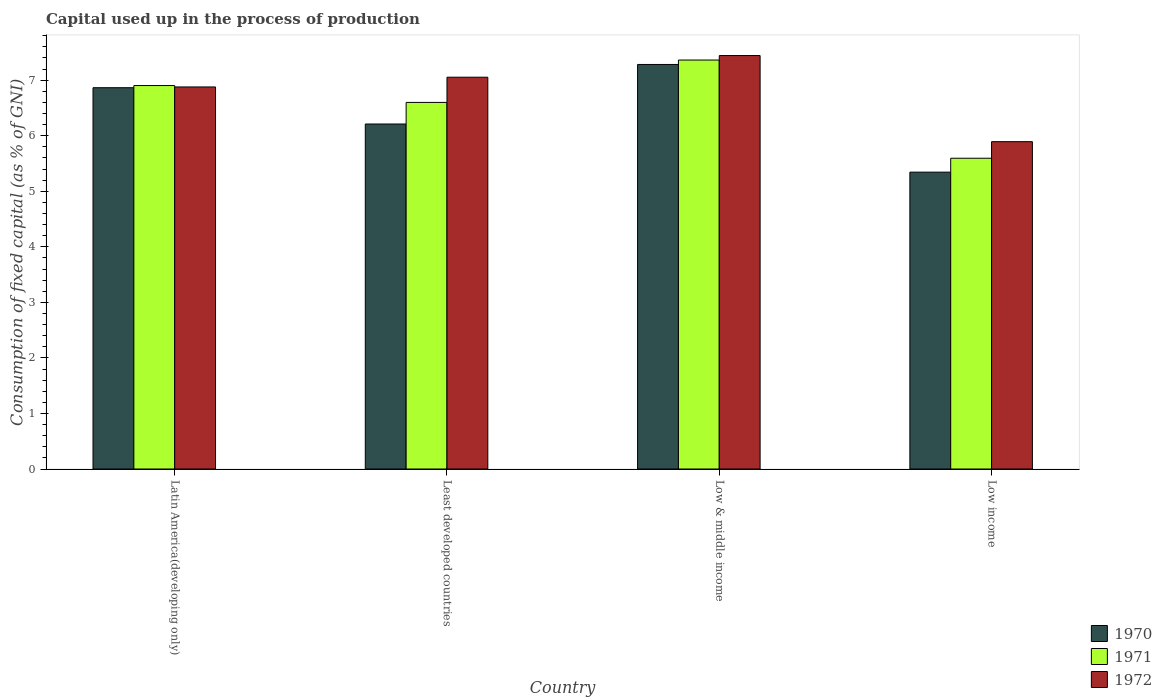How many different coloured bars are there?
Provide a short and direct response. 3. How many groups of bars are there?
Your answer should be compact. 4. How many bars are there on the 3rd tick from the left?
Provide a succinct answer. 3. How many bars are there on the 1st tick from the right?
Offer a very short reply. 3. In how many cases, is the number of bars for a given country not equal to the number of legend labels?
Offer a very short reply. 0. What is the capital used up in the process of production in 1971 in Low income?
Offer a very short reply. 5.59. Across all countries, what is the maximum capital used up in the process of production in 1972?
Ensure brevity in your answer.  7.44. Across all countries, what is the minimum capital used up in the process of production in 1970?
Ensure brevity in your answer.  5.34. What is the total capital used up in the process of production in 1970 in the graph?
Provide a succinct answer. 25.7. What is the difference between the capital used up in the process of production in 1970 in Latin America(developing only) and that in Least developed countries?
Provide a succinct answer. 0.65. What is the difference between the capital used up in the process of production in 1971 in Latin America(developing only) and the capital used up in the process of production in 1972 in Least developed countries?
Give a very brief answer. -0.15. What is the average capital used up in the process of production in 1970 per country?
Offer a very short reply. 6.42. What is the difference between the capital used up in the process of production of/in 1972 and capital used up in the process of production of/in 1971 in Least developed countries?
Offer a terse response. 0.45. In how many countries, is the capital used up in the process of production in 1972 greater than 3.6 %?
Give a very brief answer. 4. What is the ratio of the capital used up in the process of production in 1972 in Latin America(developing only) to that in Low income?
Offer a very short reply. 1.17. What is the difference between the highest and the second highest capital used up in the process of production in 1971?
Your response must be concise. -0.3. What is the difference between the highest and the lowest capital used up in the process of production in 1971?
Give a very brief answer. 1.77. What does the 3rd bar from the left in Low income represents?
Give a very brief answer. 1972. How many bars are there?
Your answer should be very brief. 12. Are all the bars in the graph horizontal?
Your response must be concise. No. How many countries are there in the graph?
Provide a succinct answer. 4. Are the values on the major ticks of Y-axis written in scientific E-notation?
Offer a very short reply. No. Does the graph contain grids?
Provide a short and direct response. No. How many legend labels are there?
Your answer should be very brief. 3. What is the title of the graph?
Ensure brevity in your answer.  Capital used up in the process of production. What is the label or title of the X-axis?
Your response must be concise. Country. What is the label or title of the Y-axis?
Your answer should be compact. Consumption of fixed capital (as % of GNI). What is the Consumption of fixed capital (as % of GNI) in 1970 in Latin America(developing only)?
Keep it short and to the point. 6.86. What is the Consumption of fixed capital (as % of GNI) in 1971 in Latin America(developing only)?
Offer a very short reply. 6.9. What is the Consumption of fixed capital (as % of GNI) in 1972 in Latin America(developing only)?
Offer a terse response. 6.88. What is the Consumption of fixed capital (as % of GNI) in 1970 in Least developed countries?
Your response must be concise. 6.21. What is the Consumption of fixed capital (as % of GNI) of 1971 in Least developed countries?
Your answer should be very brief. 6.6. What is the Consumption of fixed capital (as % of GNI) of 1972 in Least developed countries?
Your answer should be compact. 7.05. What is the Consumption of fixed capital (as % of GNI) in 1970 in Low & middle income?
Keep it short and to the point. 7.28. What is the Consumption of fixed capital (as % of GNI) of 1971 in Low & middle income?
Make the answer very short. 7.36. What is the Consumption of fixed capital (as % of GNI) in 1972 in Low & middle income?
Your answer should be very brief. 7.44. What is the Consumption of fixed capital (as % of GNI) of 1970 in Low income?
Make the answer very short. 5.34. What is the Consumption of fixed capital (as % of GNI) in 1971 in Low income?
Make the answer very short. 5.59. What is the Consumption of fixed capital (as % of GNI) of 1972 in Low income?
Ensure brevity in your answer.  5.89. Across all countries, what is the maximum Consumption of fixed capital (as % of GNI) in 1970?
Make the answer very short. 7.28. Across all countries, what is the maximum Consumption of fixed capital (as % of GNI) in 1971?
Make the answer very short. 7.36. Across all countries, what is the maximum Consumption of fixed capital (as % of GNI) in 1972?
Give a very brief answer. 7.44. Across all countries, what is the minimum Consumption of fixed capital (as % of GNI) of 1970?
Ensure brevity in your answer.  5.34. Across all countries, what is the minimum Consumption of fixed capital (as % of GNI) in 1971?
Offer a very short reply. 5.59. Across all countries, what is the minimum Consumption of fixed capital (as % of GNI) of 1972?
Make the answer very short. 5.89. What is the total Consumption of fixed capital (as % of GNI) in 1970 in the graph?
Make the answer very short. 25.7. What is the total Consumption of fixed capital (as % of GNI) in 1971 in the graph?
Offer a terse response. 26.46. What is the total Consumption of fixed capital (as % of GNI) of 1972 in the graph?
Ensure brevity in your answer.  27.27. What is the difference between the Consumption of fixed capital (as % of GNI) of 1970 in Latin America(developing only) and that in Least developed countries?
Your answer should be compact. 0.65. What is the difference between the Consumption of fixed capital (as % of GNI) in 1971 in Latin America(developing only) and that in Least developed countries?
Provide a short and direct response. 0.3. What is the difference between the Consumption of fixed capital (as % of GNI) in 1972 in Latin America(developing only) and that in Least developed countries?
Provide a succinct answer. -0.18. What is the difference between the Consumption of fixed capital (as % of GNI) of 1970 in Latin America(developing only) and that in Low & middle income?
Provide a succinct answer. -0.42. What is the difference between the Consumption of fixed capital (as % of GNI) in 1971 in Latin America(developing only) and that in Low & middle income?
Provide a short and direct response. -0.46. What is the difference between the Consumption of fixed capital (as % of GNI) in 1972 in Latin America(developing only) and that in Low & middle income?
Ensure brevity in your answer.  -0.57. What is the difference between the Consumption of fixed capital (as % of GNI) of 1970 in Latin America(developing only) and that in Low income?
Provide a succinct answer. 1.52. What is the difference between the Consumption of fixed capital (as % of GNI) of 1971 in Latin America(developing only) and that in Low income?
Make the answer very short. 1.31. What is the difference between the Consumption of fixed capital (as % of GNI) of 1970 in Least developed countries and that in Low & middle income?
Provide a short and direct response. -1.07. What is the difference between the Consumption of fixed capital (as % of GNI) of 1971 in Least developed countries and that in Low & middle income?
Provide a succinct answer. -0.76. What is the difference between the Consumption of fixed capital (as % of GNI) in 1972 in Least developed countries and that in Low & middle income?
Ensure brevity in your answer.  -0.39. What is the difference between the Consumption of fixed capital (as % of GNI) of 1970 in Least developed countries and that in Low income?
Your answer should be very brief. 0.87. What is the difference between the Consumption of fixed capital (as % of GNI) in 1972 in Least developed countries and that in Low income?
Provide a succinct answer. 1.16. What is the difference between the Consumption of fixed capital (as % of GNI) in 1970 in Low & middle income and that in Low income?
Offer a very short reply. 1.94. What is the difference between the Consumption of fixed capital (as % of GNI) in 1971 in Low & middle income and that in Low income?
Your answer should be compact. 1.77. What is the difference between the Consumption of fixed capital (as % of GNI) of 1972 in Low & middle income and that in Low income?
Offer a very short reply. 1.55. What is the difference between the Consumption of fixed capital (as % of GNI) in 1970 in Latin America(developing only) and the Consumption of fixed capital (as % of GNI) in 1971 in Least developed countries?
Provide a succinct answer. 0.26. What is the difference between the Consumption of fixed capital (as % of GNI) in 1970 in Latin America(developing only) and the Consumption of fixed capital (as % of GNI) in 1972 in Least developed countries?
Offer a very short reply. -0.19. What is the difference between the Consumption of fixed capital (as % of GNI) of 1971 in Latin America(developing only) and the Consumption of fixed capital (as % of GNI) of 1972 in Least developed countries?
Provide a succinct answer. -0.15. What is the difference between the Consumption of fixed capital (as % of GNI) of 1970 in Latin America(developing only) and the Consumption of fixed capital (as % of GNI) of 1971 in Low & middle income?
Provide a succinct answer. -0.5. What is the difference between the Consumption of fixed capital (as % of GNI) of 1970 in Latin America(developing only) and the Consumption of fixed capital (as % of GNI) of 1972 in Low & middle income?
Offer a very short reply. -0.58. What is the difference between the Consumption of fixed capital (as % of GNI) in 1971 in Latin America(developing only) and the Consumption of fixed capital (as % of GNI) in 1972 in Low & middle income?
Offer a very short reply. -0.54. What is the difference between the Consumption of fixed capital (as % of GNI) in 1970 in Latin America(developing only) and the Consumption of fixed capital (as % of GNI) in 1971 in Low income?
Keep it short and to the point. 1.27. What is the difference between the Consumption of fixed capital (as % of GNI) of 1971 in Latin America(developing only) and the Consumption of fixed capital (as % of GNI) of 1972 in Low income?
Give a very brief answer. 1.01. What is the difference between the Consumption of fixed capital (as % of GNI) of 1970 in Least developed countries and the Consumption of fixed capital (as % of GNI) of 1971 in Low & middle income?
Provide a succinct answer. -1.15. What is the difference between the Consumption of fixed capital (as % of GNI) in 1970 in Least developed countries and the Consumption of fixed capital (as % of GNI) in 1972 in Low & middle income?
Ensure brevity in your answer.  -1.23. What is the difference between the Consumption of fixed capital (as % of GNI) in 1971 in Least developed countries and the Consumption of fixed capital (as % of GNI) in 1972 in Low & middle income?
Your answer should be compact. -0.84. What is the difference between the Consumption of fixed capital (as % of GNI) in 1970 in Least developed countries and the Consumption of fixed capital (as % of GNI) in 1971 in Low income?
Your answer should be compact. 0.62. What is the difference between the Consumption of fixed capital (as % of GNI) in 1970 in Least developed countries and the Consumption of fixed capital (as % of GNI) in 1972 in Low income?
Your answer should be compact. 0.32. What is the difference between the Consumption of fixed capital (as % of GNI) in 1971 in Least developed countries and the Consumption of fixed capital (as % of GNI) in 1972 in Low income?
Your answer should be compact. 0.71. What is the difference between the Consumption of fixed capital (as % of GNI) of 1970 in Low & middle income and the Consumption of fixed capital (as % of GNI) of 1971 in Low income?
Keep it short and to the point. 1.69. What is the difference between the Consumption of fixed capital (as % of GNI) of 1970 in Low & middle income and the Consumption of fixed capital (as % of GNI) of 1972 in Low income?
Keep it short and to the point. 1.39. What is the difference between the Consumption of fixed capital (as % of GNI) of 1971 in Low & middle income and the Consumption of fixed capital (as % of GNI) of 1972 in Low income?
Your response must be concise. 1.47. What is the average Consumption of fixed capital (as % of GNI) of 1970 per country?
Offer a terse response. 6.42. What is the average Consumption of fixed capital (as % of GNI) in 1971 per country?
Provide a short and direct response. 6.61. What is the average Consumption of fixed capital (as % of GNI) of 1972 per country?
Your answer should be very brief. 6.82. What is the difference between the Consumption of fixed capital (as % of GNI) of 1970 and Consumption of fixed capital (as % of GNI) of 1971 in Latin America(developing only)?
Ensure brevity in your answer.  -0.04. What is the difference between the Consumption of fixed capital (as % of GNI) in 1970 and Consumption of fixed capital (as % of GNI) in 1972 in Latin America(developing only)?
Make the answer very short. -0.01. What is the difference between the Consumption of fixed capital (as % of GNI) in 1971 and Consumption of fixed capital (as % of GNI) in 1972 in Latin America(developing only)?
Offer a very short reply. 0.03. What is the difference between the Consumption of fixed capital (as % of GNI) of 1970 and Consumption of fixed capital (as % of GNI) of 1971 in Least developed countries?
Offer a terse response. -0.39. What is the difference between the Consumption of fixed capital (as % of GNI) in 1970 and Consumption of fixed capital (as % of GNI) in 1972 in Least developed countries?
Your answer should be very brief. -0.84. What is the difference between the Consumption of fixed capital (as % of GNI) of 1971 and Consumption of fixed capital (as % of GNI) of 1972 in Least developed countries?
Make the answer very short. -0.45. What is the difference between the Consumption of fixed capital (as % of GNI) of 1970 and Consumption of fixed capital (as % of GNI) of 1971 in Low & middle income?
Keep it short and to the point. -0.08. What is the difference between the Consumption of fixed capital (as % of GNI) of 1970 and Consumption of fixed capital (as % of GNI) of 1972 in Low & middle income?
Keep it short and to the point. -0.16. What is the difference between the Consumption of fixed capital (as % of GNI) in 1971 and Consumption of fixed capital (as % of GNI) in 1972 in Low & middle income?
Offer a very short reply. -0.08. What is the difference between the Consumption of fixed capital (as % of GNI) in 1970 and Consumption of fixed capital (as % of GNI) in 1971 in Low income?
Make the answer very short. -0.25. What is the difference between the Consumption of fixed capital (as % of GNI) in 1970 and Consumption of fixed capital (as % of GNI) in 1972 in Low income?
Offer a terse response. -0.55. What is the difference between the Consumption of fixed capital (as % of GNI) in 1971 and Consumption of fixed capital (as % of GNI) in 1972 in Low income?
Ensure brevity in your answer.  -0.3. What is the ratio of the Consumption of fixed capital (as % of GNI) of 1970 in Latin America(developing only) to that in Least developed countries?
Provide a short and direct response. 1.11. What is the ratio of the Consumption of fixed capital (as % of GNI) of 1971 in Latin America(developing only) to that in Least developed countries?
Give a very brief answer. 1.05. What is the ratio of the Consumption of fixed capital (as % of GNI) in 1972 in Latin America(developing only) to that in Least developed countries?
Offer a very short reply. 0.98. What is the ratio of the Consumption of fixed capital (as % of GNI) of 1970 in Latin America(developing only) to that in Low & middle income?
Provide a short and direct response. 0.94. What is the ratio of the Consumption of fixed capital (as % of GNI) of 1971 in Latin America(developing only) to that in Low & middle income?
Offer a very short reply. 0.94. What is the ratio of the Consumption of fixed capital (as % of GNI) of 1972 in Latin America(developing only) to that in Low & middle income?
Keep it short and to the point. 0.92. What is the ratio of the Consumption of fixed capital (as % of GNI) in 1970 in Latin America(developing only) to that in Low income?
Your answer should be compact. 1.28. What is the ratio of the Consumption of fixed capital (as % of GNI) in 1971 in Latin America(developing only) to that in Low income?
Provide a short and direct response. 1.23. What is the ratio of the Consumption of fixed capital (as % of GNI) of 1972 in Latin America(developing only) to that in Low income?
Your answer should be very brief. 1.17. What is the ratio of the Consumption of fixed capital (as % of GNI) of 1970 in Least developed countries to that in Low & middle income?
Provide a short and direct response. 0.85. What is the ratio of the Consumption of fixed capital (as % of GNI) of 1971 in Least developed countries to that in Low & middle income?
Offer a terse response. 0.9. What is the ratio of the Consumption of fixed capital (as % of GNI) in 1972 in Least developed countries to that in Low & middle income?
Provide a succinct answer. 0.95. What is the ratio of the Consumption of fixed capital (as % of GNI) in 1970 in Least developed countries to that in Low income?
Your answer should be very brief. 1.16. What is the ratio of the Consumption of fixed capital (as % of GNI) in 1971 in Least developed countries to that in Low income?
Keep it short and to the point. 1.18. What is the ratio of the Consumption of fixed capital (as % of GNI) of 1972 in Least developed countries to that in Low income?
Offer a very short reply. 1.2. What is the ratio of the Consumption of fixed capital (as % of GNI) in 1970 in Low & middle income to that in Low income?
Offer a terse response. 1.36. What is the ratio of the Consumption of fixed capital (as % of GNI) in 1971 in Low & middle income to that in Low income?
Your response must be concise. 1.32. What is the ratio of the Consumption of fixed capital (as % of GNI) of 1972 in Low & middle income to that in Low income?
Provide a succinct answer. 1.26. What is the difference between the highest and the second highest Consumption of fixed capital (as % of GNI) of 1970?
Your answer should be compact. 0.42. What is the difference between the highest and the second highest Consumption of fixed capital (as % of GNI) in 1971?
Provide a succinct answer. 0.46. What is the difference between the highest and the second highest Consumption of fixed capital (as % of GNI) in 1972?
Make the answer very short. 0.39. What is the difference between the highest and the lowest Consumption of fixed capital (as % of GNI) in 1970?
Your response must be concise. 1.94. What is the difference between the highest and the lowest Consumption of fixed capital (as % of GNI) of 1971?
Keep it short and to the point. 1.77. What is the difference between the highest and the lowest Consumption of fixed capital (as % of GNI) in 1972?
Offer a terse response. 1.55. 